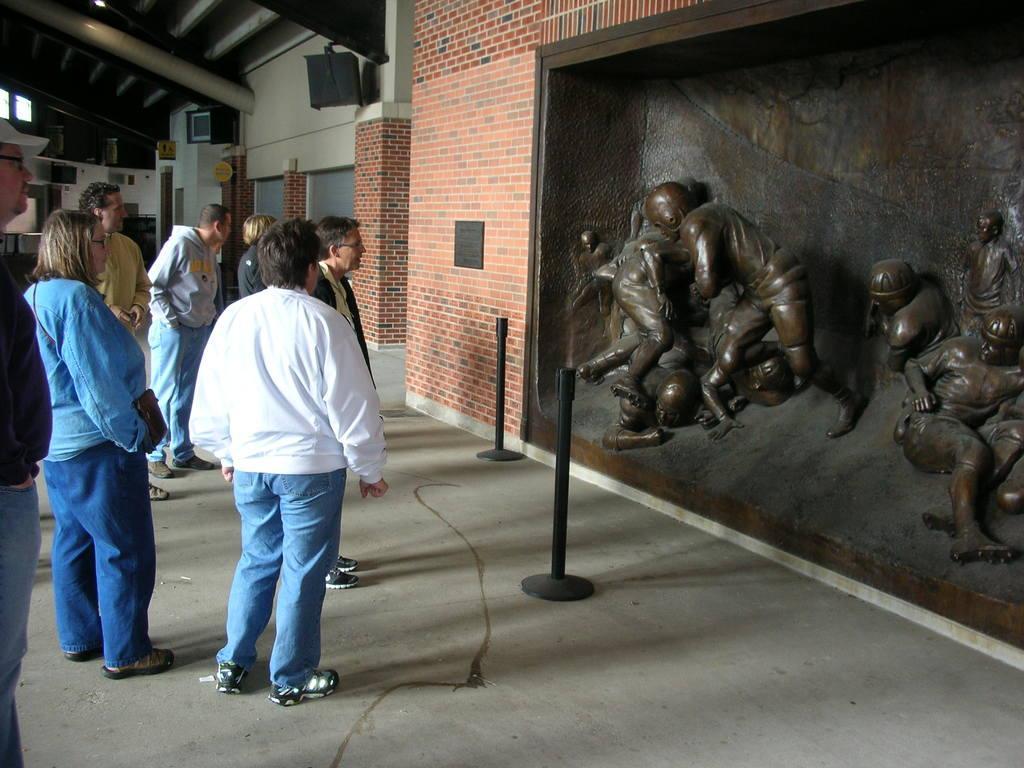Can you describe this image briefly? In this image there are group of people standing on the floor and looking at the sculptures which are in front of them. At the top there is ceiling. In the background there is a wall. In front of them there are two poles. The sculptures are fixed inside the wall. At the top there are two televisions which are attached to the roof. 